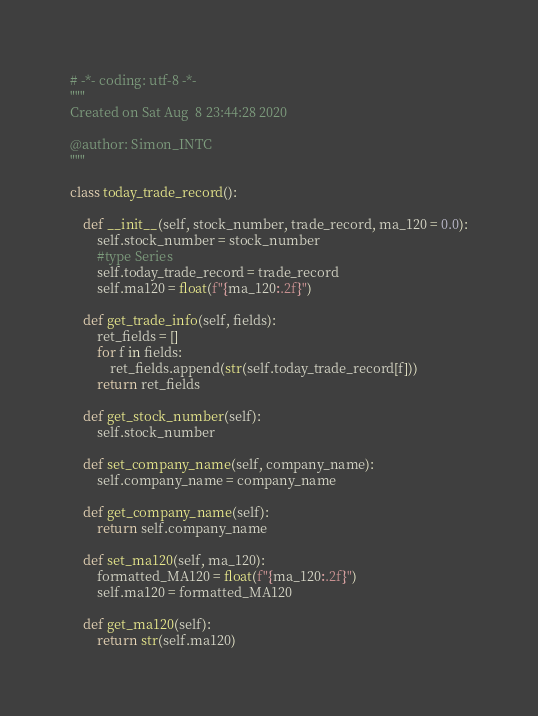<code> <loc_0><loc_0><loc_500><loc_500><_Python_># -*- coding: utf-8 -*-
"""
Created on Sat Aug  8 23:44:28 2020

@author: Simon_INTC
"""

class today_trade_record():
    
    def __init__(self, stock_number, trade_record, ma_120 = 0.0):
        self.stock_number = stock_number
        #type Series
        self.today_trade_record = trade_record
        self.ma120 = float(f"{ma_120:.2f}")
        
    def get_trade_info(self, fields):
        ret_fields = []
        for f in fields:
            ret_fields.append(str(self.today_trade_record[f]))
        return ret_fields
    
    def get_stock_number(self):
        self.stock_number
    
    def set_company_name(self, company_name):
        self.company_name = company_name
        
    def get_company_name(self):
        return self.company_name
        
    def set_ma120(self, ma_120):
        formatted_MA120 = float(f"{ma_120:.2f}")
        self.ma120 = formatted_MA120
        
    def get_ma120(self):
        return str(self.ma120)</code> 